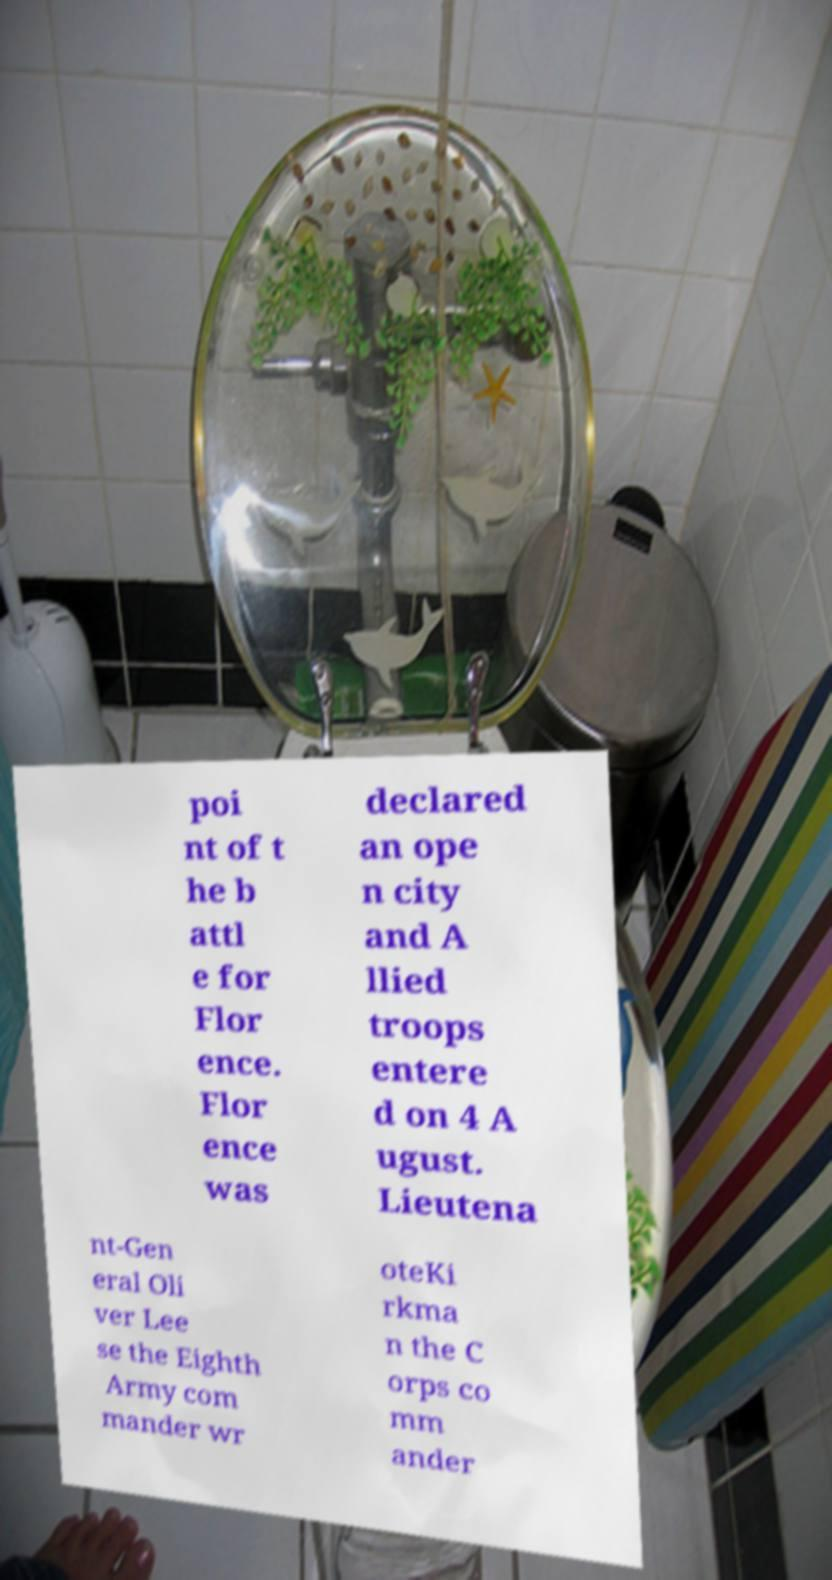Could you extract and type out the text from this image? poi nt of t he b attl e for Flor ence. Flor ence was declared an ope n city and A llied troops entere d on 4 A ugust. Lieutena nt-Gen eral Oli ver Lee se the Eighth Army com mander wr oteKi rkma n the C orps co mm ander 